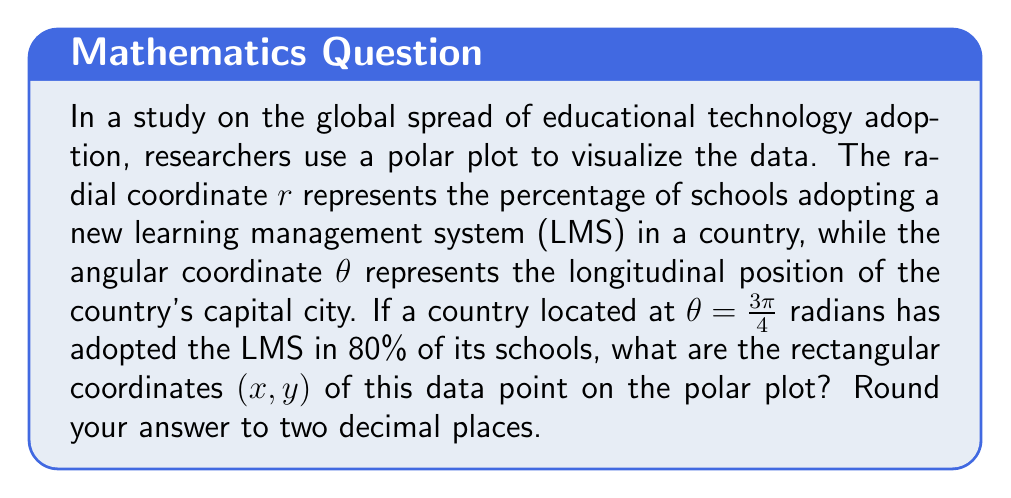Could you help me with this problem? To solve this problem, we need to convert the given polar coordinates to rectangular coordinates. Let's approach this step-by-step:

1) We are given the following polar coordinates:
   $r = 80$ (representing 80% adoption)
   $\theta = \frac{3\pi}{4}$ radians

2) The formulas for converting from polar coordinates $(r,\theta)$ to rectangular coordinates $(x,y)$ are:
   
   $x = r \cos(\theta)$
   $y = r \sin(\theta)$

3) Let's calculate $x$ first:
   
   $x = 80 \cos(\frac{3\pi}{4})$
   
   $\cos(\frac{3\pi}{4}) = -\frac{\sqrt{2}}{2}$
   
   So, $x = 80 \cdot (-\frac{\sqrt{2}}{2}) = -40\sqrt{2} \approx -56.57$

4) Now let's calculate $y$:
   
   $y = 80 \sin(\frac{3\pi}{4})$
   
   $\sin(\frac{3\pi}{4}) = \frac{\sqrt{2}}{2}$
   
   So, $y = 80 \cdot \frac{\sqrt{2}}{2} = 40\sqrt{2} \approx 56.57$

5) Rounding to two decimal places:
   $x \approx -56.57$
   $y \approx 56.57$

Therefore, the rectangular coordinates are approximately $(-56.57, 56.57)$.
Answer: $(-56.57, 56.57)$ 